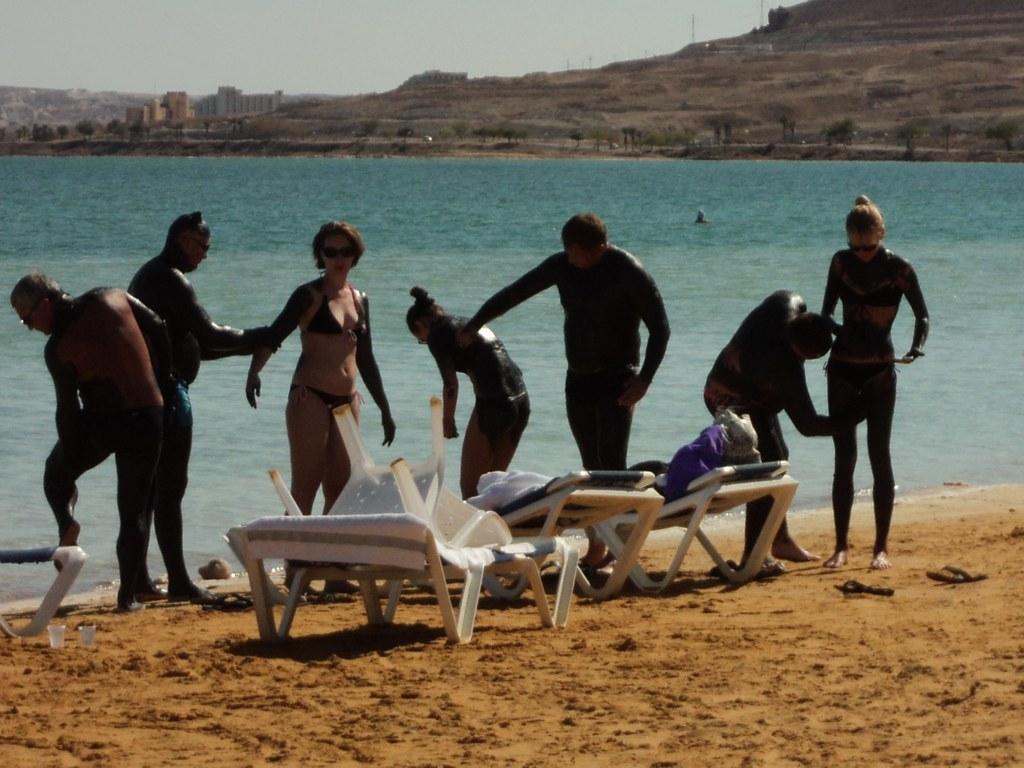Can you describe this image briefly? In the foreground of this image, there are persons near a beach and there are chairs, beds on the ground. In the background, there is water, buildings and the sky. 